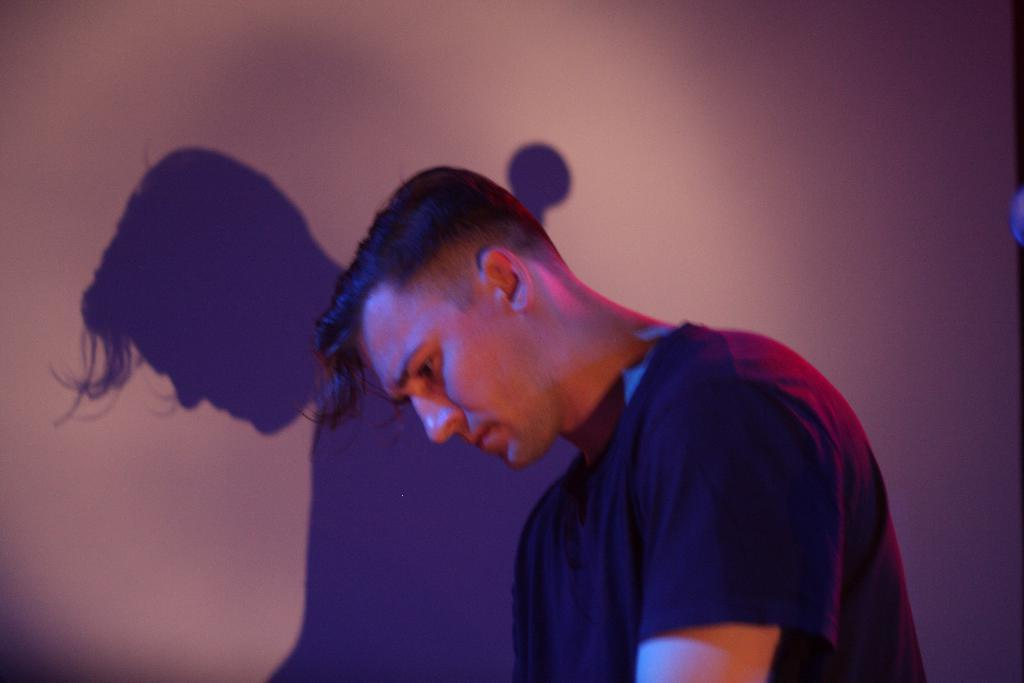What is the main subject of the image? There is a man in the image. What is the man doing in the image? The man is standing. Can you describe any additional features in the image related to the man? There is a shadow of the man on the wall in the image. How does the man increase the power of the lizards in the image? There are no lizards present in the image, and the man is not shown doing anything to increase power. 